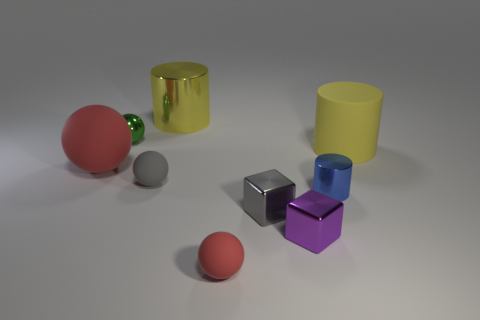Subtract all gray spheres. How many spheres are left? 3 Subtract all gray balls. How many yellow cylinders are left? 2 Subtract all green balls. How many balls are left? 3 Add 1 small cyan matte things. How many objects exist? 10 Subtract all purple cylinders. Subtract all green blocks. How many cylinders are left? 3 Subtract all cubes. How many objects are left? 7 Add 8 big shiny cylinders. How many big shiny cylinders are left? 9 Add 6 rubber things. How many rubber things exist? 10 Subtract 0 red cylinders. How many objects are left? 9 Subtract all big brown shiny blocks. Subtract all large red objects. How many objects are left? 8 